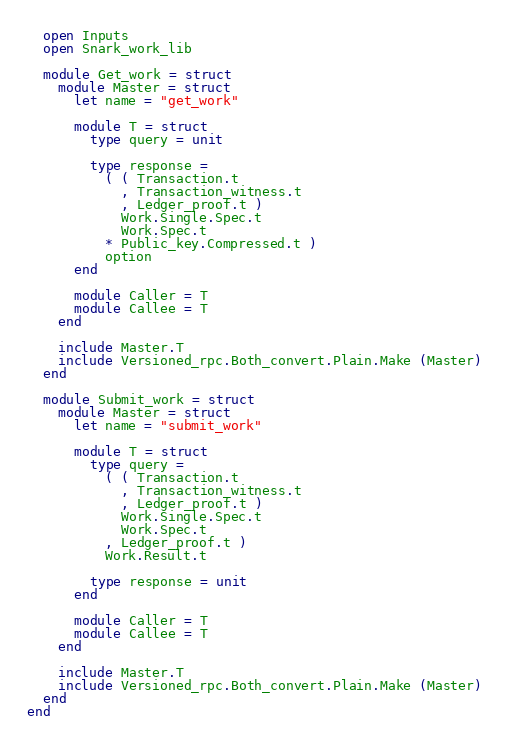Convert code to text. <code><loc_0><loc_0><loc_500><loc_500><_OCaml_>  open Inputs
  open Snark_work_lib

  module Get_work = struct
    module Master = struct
      let name = "get_work"

      module T = struct
        type query = unit

        type response =
          ( ( Transaction.t
            , Transaction_witness.t
            , Ledger_proof.t )
            Work.Single.Spec.t
            Work.Spec.t
          * Public_key.Compressed.t )
          option
      end

      module Caller = T
      module Callee = T
    end

    include Master.T
    include Versioned_rpc.Both_convert.Plain.Make (Master)
  end

  module Submit_work = struct
    module Master = struct
      let name = "submit_work"

      module T = struct
        type query =
          ( ( Transaction.t
            , Transaction_witness.t
            , Ledger_proof.t )
            Work.Single.Spec.t
            Work.Spec.t
          , Ledger_proof.t )
          Work.Result.t

        type response = unit
      end

      module Caller = T
      module Callee = T
    end

    include Master.T
    include Versioned_rpc.Both_convert.Plain.Make (Master)
  end
end
</code> 